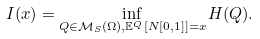Convert formula to latex. <formula><loc_0><loc_0><loc_500><loc_500>I ( x ) = \inf _ { Q \in \mathcal { M } _ { S } ( \Omega ) , \mathbb { E } ^ { Q } [ N [ 0 , 1 ] ] = x } H ( Q ) .</formula> 